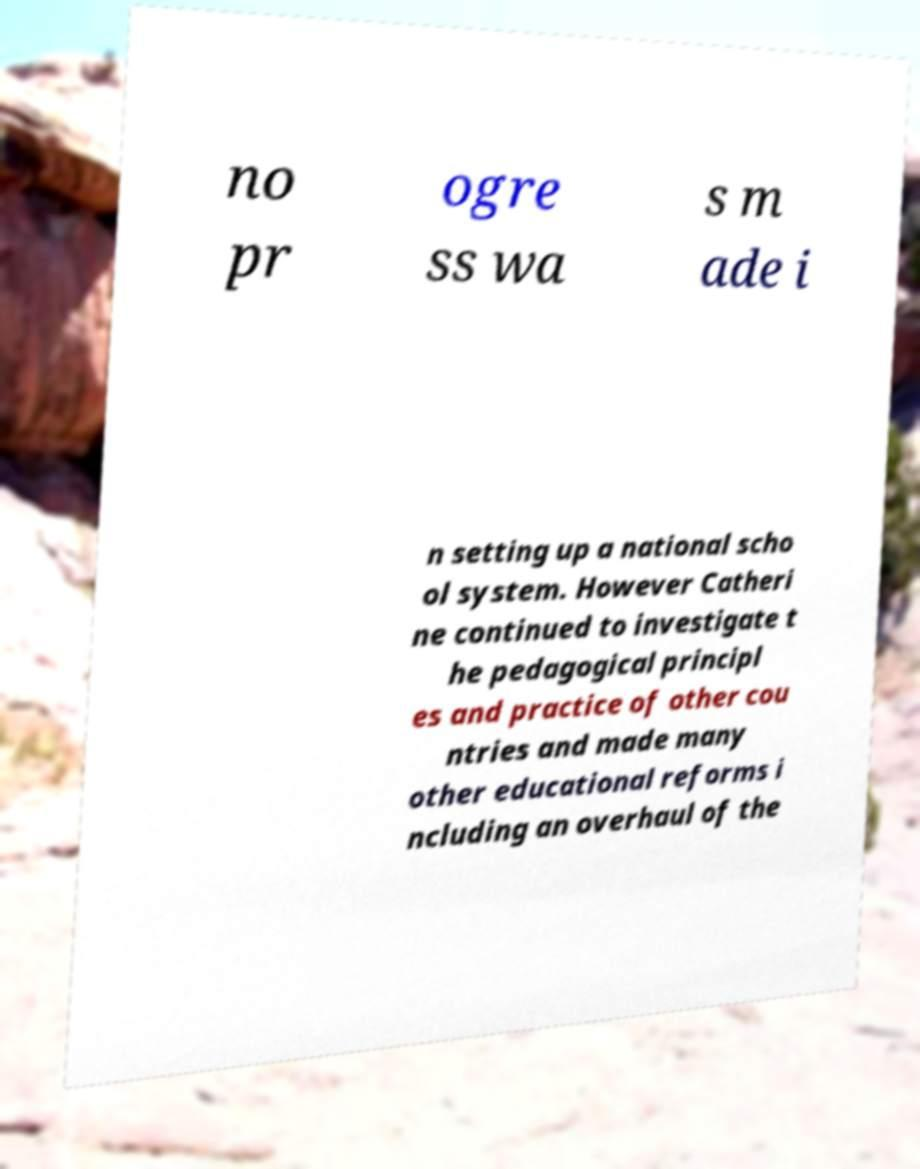Please identify and transcribe the text found in this image. no pr ogre ss wa s m ade i n setting up a national scho ol system. However Catheri ne continued to investigate t he pedagogical principl es and practice of other cou ntries and made many other educational reforms i ncluding an overhaul of the 